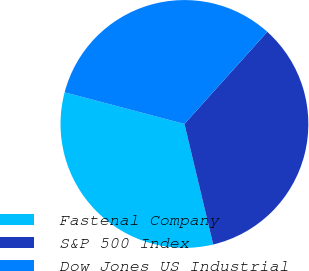<chart> <loc_0><loc_0><loc_500><loc_500><pie_chart><fcel>Fastenal Company<fcel>S&P 500 Index<fcel>Dow Jones US Industrial<nl><fcel>32.84%<fcel>34.61%<fcel>32.54%<nl></chart> 